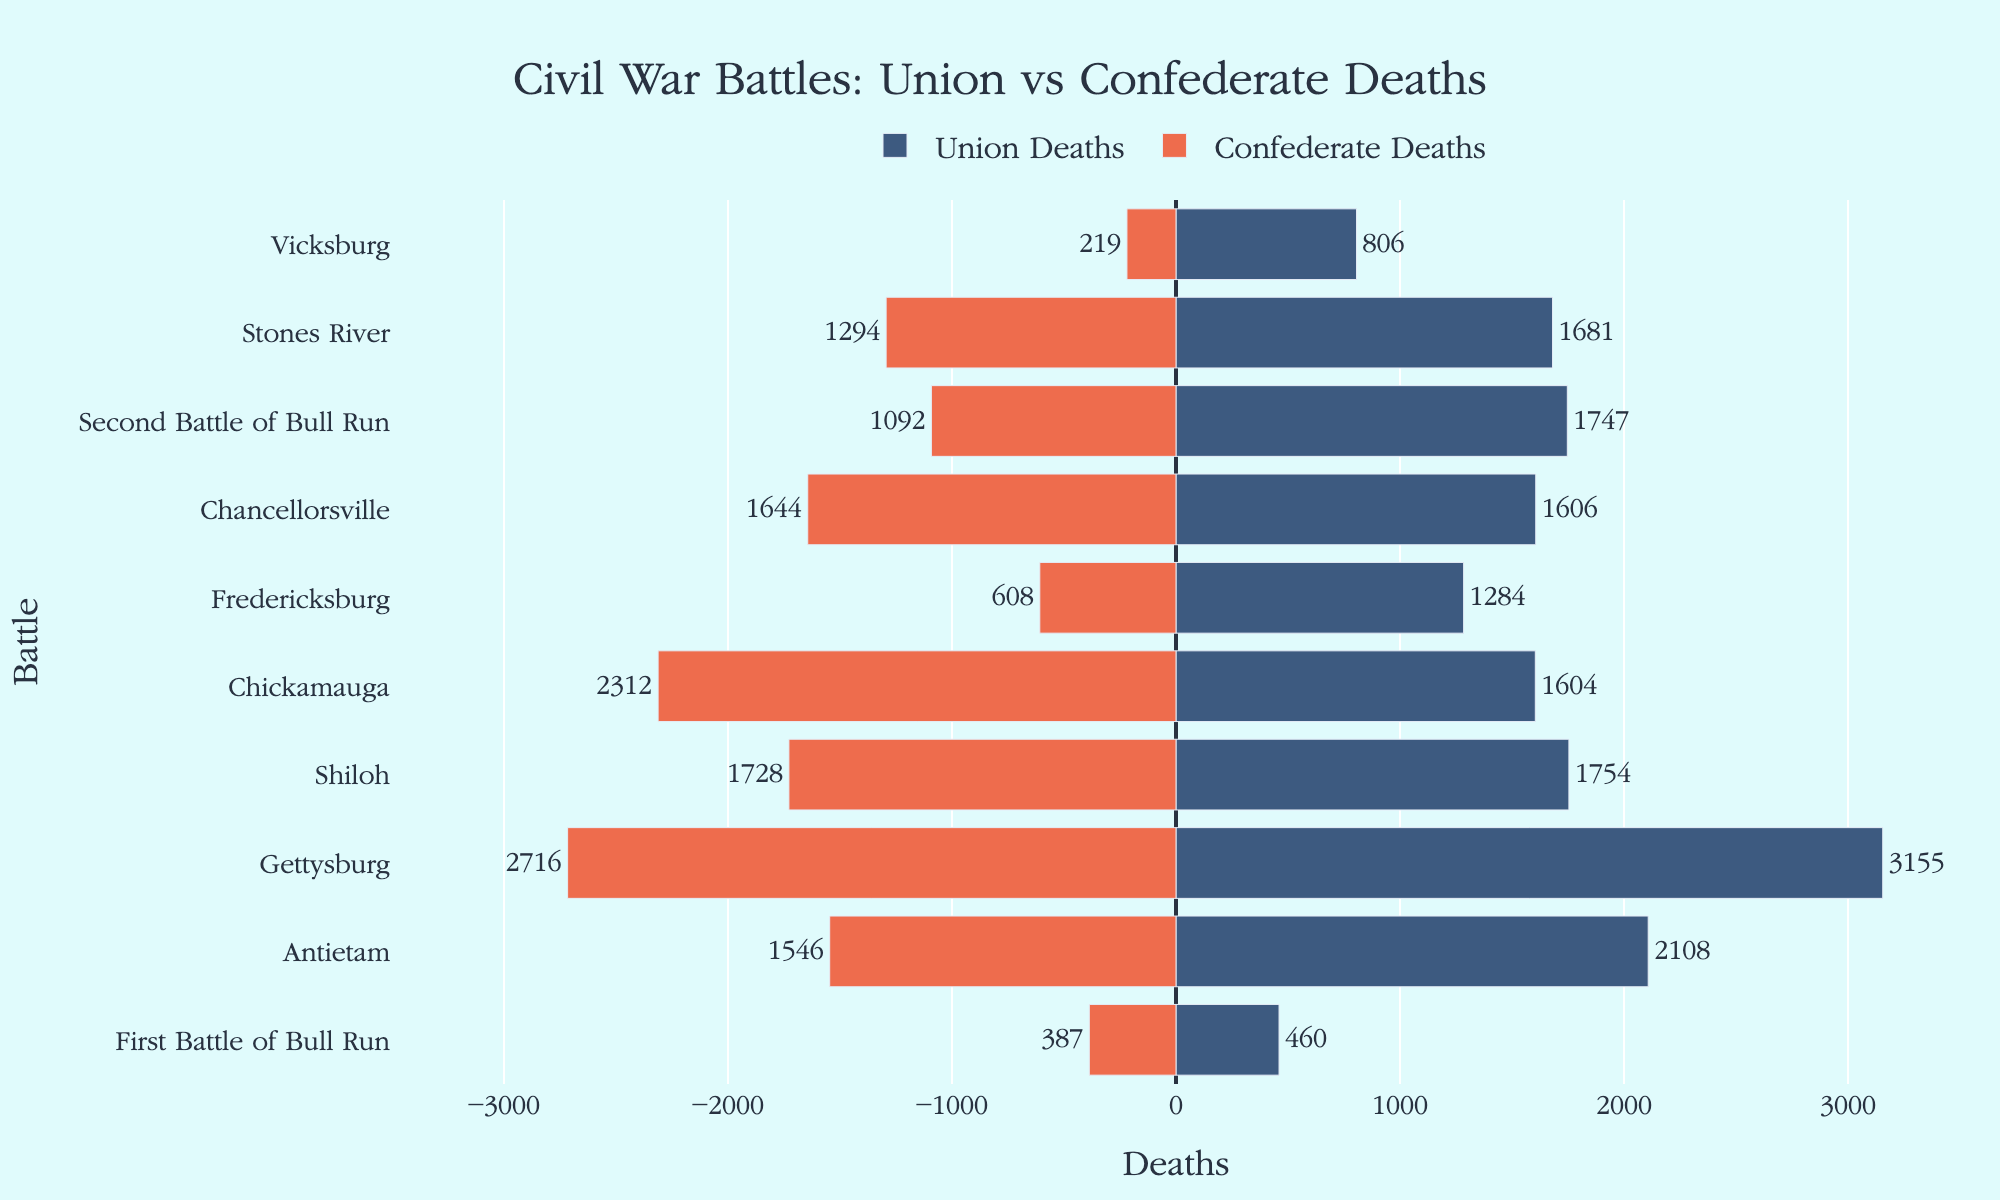Which battle had the greatest number of Union deaths? The longest blue bar on the positive side of the chart indicates the Union deaths. The battle with the longest blue bar is "Gettysburg" with 3155 Union deaths.
Answer: Gettysburg What is the difference in Confederate deaths between the Battle of Antietam and the Battle of Chickamauga? The Confederate deaths at Antietam are 1546 and at Chickamauga are 2312. The difference is 2312 - 1546 = 766.
Answer: 766 Which side had more deaths in the Second Battle of Bull Run? Compare the lengths of the bars for Union and Confederate deaths for the Second Battle of Bull Run. The blue bar representing Union deaths is longer (1747) compared to the red bar representing Confederate deaths (1092).
Answer: Union What is the average number of deaths among Union soldiers in the listed battles? Sum of Union deaths: 460 + 2108 + 3155 + 1754 + 1604 + 1284 + 1606 + 1747 + 1681 + 806 = 16105. Number of battles = 10. Average = 16105 / 10 = 1610.5.
Answer: 1610.5 Which battle had the smallest variance in deaths between the opposing sides? The variance values between Union and Confederate deaths for each battle are checked. The smallest variance is at Fredericksburg with 10 for Union and -16 for Confederate. Absolute values give the smallest variance as 6 for Vicksburg.
Answer: Vicksburg How many more Confederate soldiers died at Chickamauga compared to Union soldiers? Confederate deaths at Chickamauga are 2312 and Union deaths are 1604. The difference is 2312 - 1604 = 708.
Answer: 708 Which battles have more Union deaths than Confederate deaths? Identify battles where the blue bars (Union deaths) are longer than the red bars (Confederate deaths). These battles are First Battle of Bull Run, Antietam, Gettysburg, Shiloh, Second Battle of Bull Run, Stones River, and Vicksburg.
Answer: First Battle of Bull Run, Antietam, Gettysburg, Shiloh, Second Battle of Bull Run, Stones River, Vicksburg How does the length of the bar for Union deaths at the Battle of Shiloh compare with the Battle of Fredericksburg? Compare the lengths of the blue bars for the given battles. Shiloh (1754) has a longer bar than Fredericksburg (1284).
Answer: Shiloh is longer What is the total death count for Confederate soldiers across all listed battles? Sum of Confederate deaths: 387 + 1546 + 2716 + 1728 + 2312 + 608 + 1644 + 1092 + 1294 + 219 = 13546. Total= 13546.
Answer: 13546 